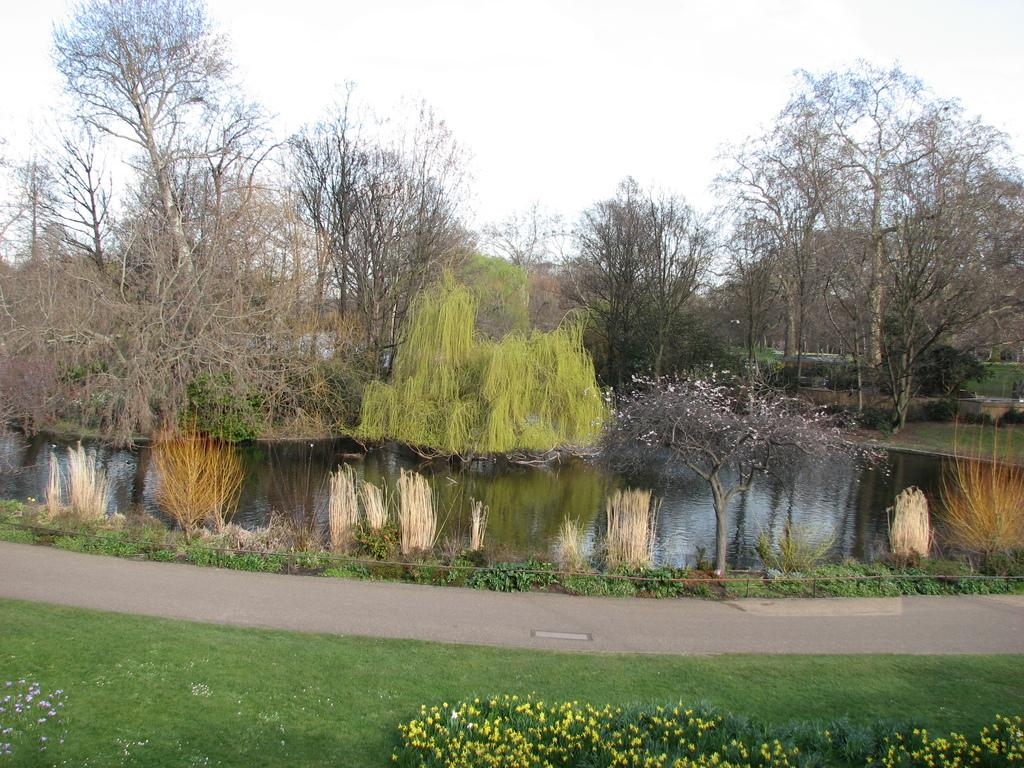What type of vegetation is present on the ground in the image? There is grass on the ground in the image. What other types of vegetation can be seen in the image? There are plants and yellow flowers in the image. What man-made structure is visible in the image? There is a road in the image. What natural element is visible in the image? There is water visible in the image. What type of trees are present in the image? There are trees in the image. What is visible in the background of the image? The sky is visible in the background of the image. What type of sugar is being used to sweeten the honey in the image? There is no sugar or honey present in the image; it features natural elements such as grass, plants, yellow flowers, a road, water, trees, and the sky. How many dolls are visible in the image? There are no dolls present in the image. 